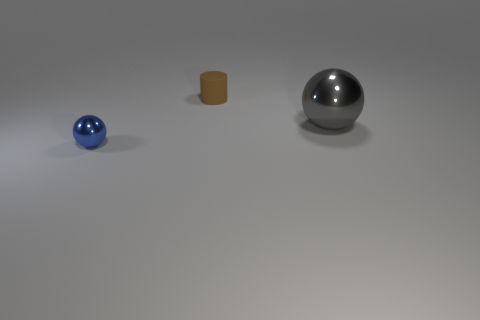Add 3 small metal blocks. How many objects exist? 6 Subtract all cylinders. How many objects are left? 2 Add 2 small gray metallic blocks. How many small gray metallic blocks exist? 2 Subtract 1 blue balls. How many objects are left? 2 Subtract all brown matte cylinders. Subtract all small rubber cylinders. How many objects are left? 1 Add 1 brown objects. How many brown objects are left? 2 